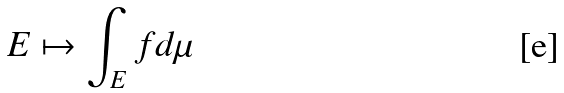Convert formula to latex. <formula><loc_0><loc_0><loc_500><loc_500>E \mapsto \int _ { E } f d \mu</formula> 